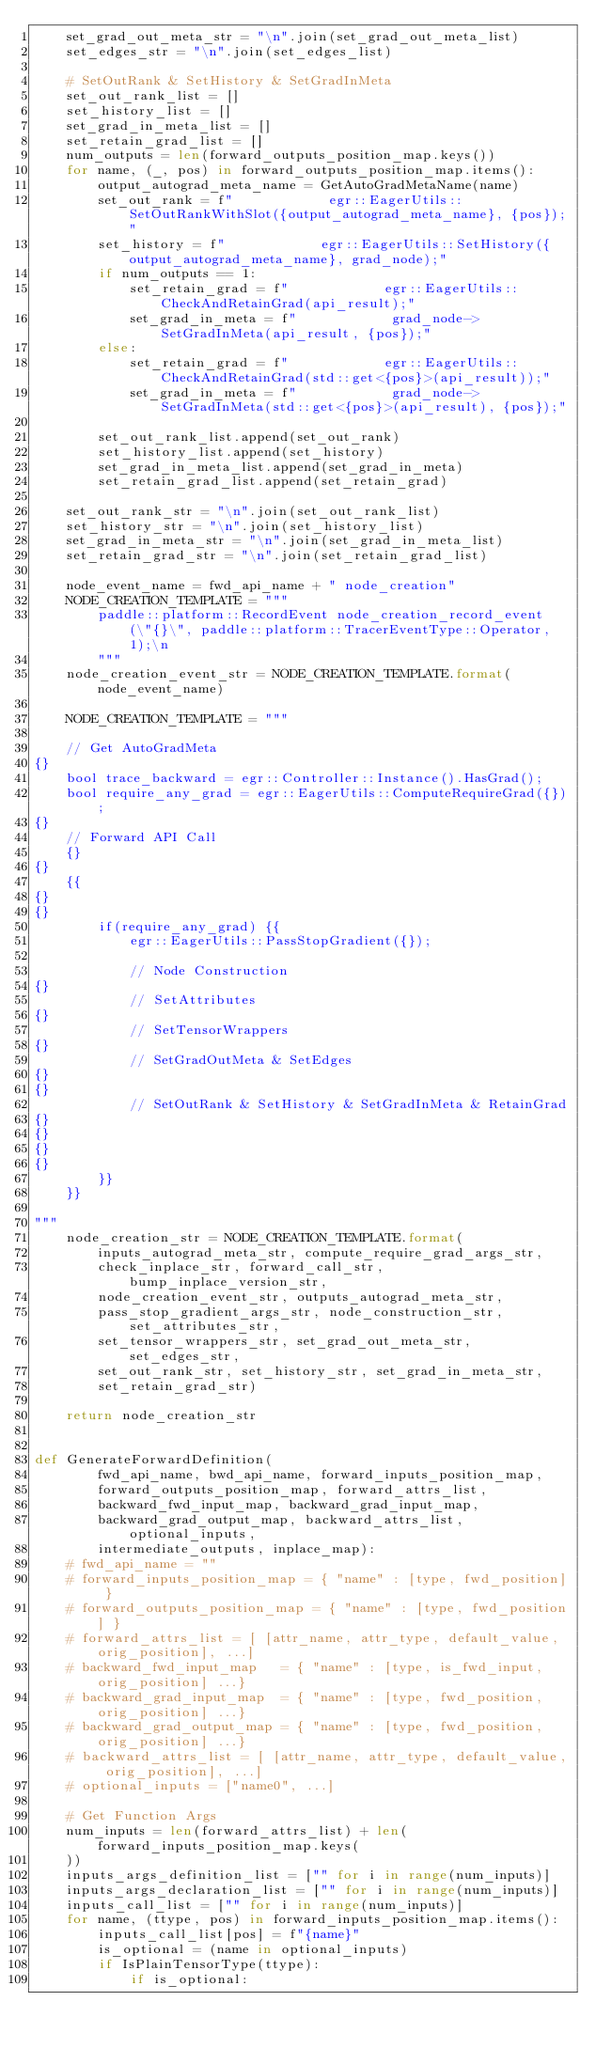<code> <loc_0><loc_0><loc_500><loc_500><_Python_>    set_grad_out_meta_str = "\n".join(set_grad_out_meta_list)
    set_edges_str = "\n".join(set_edges_list)

    # SetOutRank & SetHistory & SetGradInMeta
    set_out_rank_list = []
    set_history_list = []
    set_grad_in_meta_list = []
    set_retain_grad_list = []
    num_outputs = len(forward_outputs_position_map.keys())
    for name, (_, pos) in forward_outputs_position_map.items():
        output_autograd_meta_name = GetAutoGradMetaName(name)
        set_out_rank = f"            egr::EagerUtils::SetOutRankWithSlot({output_autograd_meta_name}, {pos});"
        set_history = f"            egr::EagerUtils::SetHistory({output_autograd_meta_name}, grad_node);"
        if num_outputs == 1:
            set_retain_grad = f"            egr::EagerUtils::CheckAndRetainGrad(api_result);"
            set_grad_in_meta = f"            grad_node->SetGradInMeta(api_result, {pos});"
        else:
            set_retain_grad = f"            egr::EagerUtils::CheckAndRetainGrad(std::get<{pos}>(api_result));"
            set_grad_in_meta = f"            grad_node->SetGradInMeta(std::get<{pos}>(api_result), {pos});"

        set_out_rank_list.append(set_out_rank)
        set_history_list.append(set_history)
        set_grad_in_meta_list.append(set_grad_in_meta)
        set_retain_grad_list.append(set_retain_grad)

    set_out_rank_str = "\n".join(set_out_rank_list)
    set_history_str = "\n".join(set_history_list)
    set_grad_in_meta_str = "\n".join(set_grad_in_meta_list)
    set_retain_grad_str = "\n".join(set_retain_grad_list)

    node_event_name = fwd_api_name + " node_creation"
    NODE_CREATION_TEMPLATE = """
        paddle::platform::RecordEvent node_creation_record_event(\"{}\", paddle::platform::TracerEventType::Operator, 1);\n
        """
    node_creation_event_str = NODE_CREATION_TEMPLATE.format(node_event_name)

    NODE_CREATION_TEMPLATE = """

    // Get AutoGradMeta
{}
    bool trace_backward = egr::Controller::Instance().HasGrad();
    bool require_any_grad = egr::EagerUtils::ComputeRequireGrad({});
{}
    // Forward API Call
    {}
{}
    {{
{}
{}
        if(require_any_grad) {{
            egr::EagerUtils::PassStopGradient({});
            
            // Node Construction
{}
            // SetAttributes
{}
            // SetTensorWrappers
{}
            // SetGradOutMeta & SetEdges
{}
{}
            // SetOutRank & SetHistory & SetGradInMeta & RetainGrad
{}
{}
{}
{}
        }}
    }}

"""
    node_creation_str = NODE_CREATION_TEMPLATE.format(
        inputs_autograd_meta_str, compute_require_grad_args_str,
        check_inplace_str, forward_call_str, bump_inplace_version_str,
        node_creation_event_str, outputs_autograd_meta_str,
        pass_stop_gradient_args_str, node_construction_str, set_attributes_str,
        set_tensor_wrappers_str, set_grad_out_meta_str, set_edges_str,
        set_out_rank_str, set_history_str, set_grad_in_meta_str,
        set_retain_grad_str)

    return node_creation_str


def GenerateForwardDefinition(
        fwd_api_name, bwd_api_name, forward_inputs_position_map,
        forward_outputs_position_map, forward_attrs_list,
        backward_fwd_input_map, backward_grad_input_map,
        backward_grad_output_map, backward_attrs_list, optional_inputs,
        intermediate_outputs, inplace_map):
    # fwd_api_name = ""
    # forward_inputs_position_map = { "name" : [type, fwd_position] }
    # forward_outputs_position_map = { "name" : [type, fwd_position] }
    # forward_attrs_list = [ [attr_name, attr_type, default_value, orig_position], ...]
    # backward_fwd_input_map   = { "name" : [type, is_fwd_input, orig_position] ...}
    # backward_grad_input_map  = { "name" : [type, fwd_position, orig_position] ...}
    # backward_grad_output_map = { "name" : [type, fwd_position, orig_position] ...}
    # backward_attrs_list = [ [attr_name, attr_type, default_value, orig_position], ...]
    # optional_inputs = ["name0", ...]

    # Get Function Args
    num_inputs = len(forward_attrs_list) + len(forward_inputs_position_map.keys(
    ))
    inputs_args_definition_list = ["" for i in range(num_inputs)]
    inputs_args_declaration_list = ["" for i in range(num_inputs)]
    inputs_call_list = ["" for i in range(num_inputs)]
    for name, (ttype, pos) in forward_inputs_position_map.items():
        inputs_call_list[pos] = f"{name}"
        is_optional = (name in optional_inputs)
        if IsPlainTensorType(ttype):
            if is_optional:</code> 